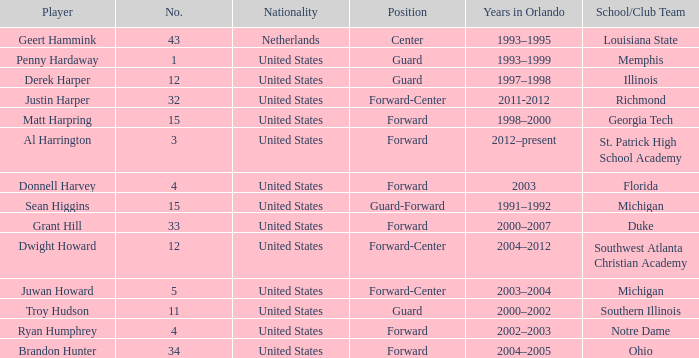What jersey number did Al Harrington wear 3.0. 